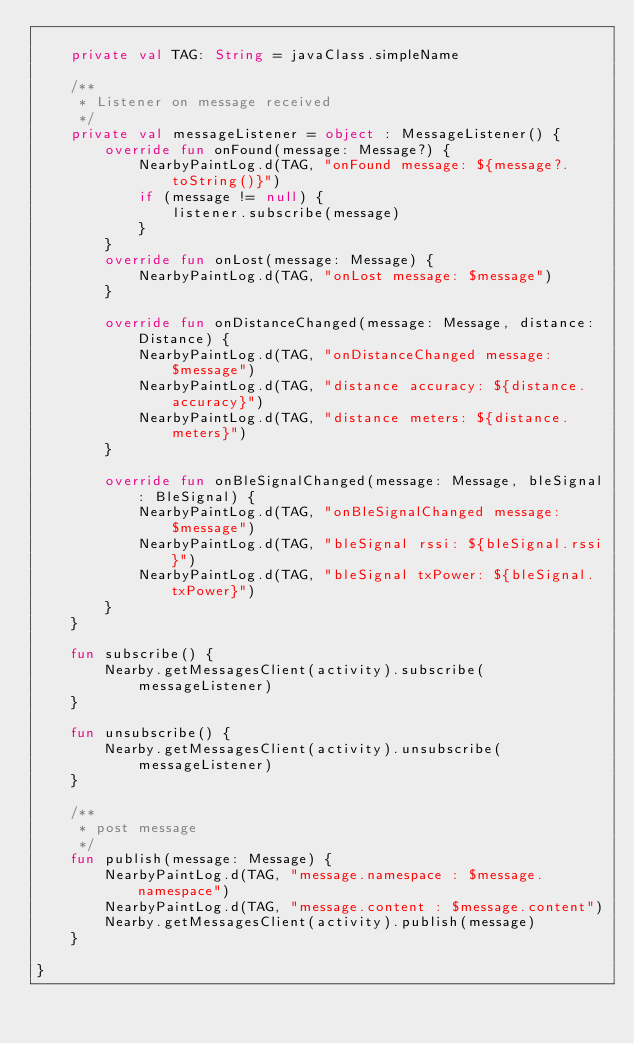Convert code to text. <code><loc_0><loc_0><loc_500><loc_500><_Kotlin_>
    private val TAG: String = javaClass.simpleName

    /**
     * Listener on message received
     */
    private val messageListener = object : MessageListener() {
        override fun onFound(message: Message?) {
            NearbyPaintLog.d(TAG, "onFound message: ${message?.toString()}")
            if (message != null) {
                listener.subscribe(message)
            }
        }
        override fun onLost(message: Message) {
            NearbyPaintLog.d(TAG, "onLost message: $message")
        }

        override fun onDistanceChanged(message: Message, distance: Distance) {
            NearbyPaintLog.d(TAG, "onDistanceChanged message: $message")
            NearbyPaintLog.d(TAG, "distance accuracy: ${distance.accuracy}")
            NearbyPaintLog.d(TAG, "distance meters: ${distance.meters}")
        }

        override fun onBleSignalChanged(message: Message, bleSignal: BleSignal) {
            NearbyPaintLog.d(TAG, "onBleSignalChanged message: $message")
            NearbyPaintLog.d(TAG, "bleSignal rssi: ${bleSignal.rssi}")
            NearbyPaintLog.d(TAG, "bleSignal txPower: ${bleSignal.txPower}")
        }
    }

    fun subscribe() {
        Nearby.getMessagesClient(activity).subscribe(messageListener)
    }

    fun unsubscribe() {
        Nearby.getMessagesClient(activity).unsubscribe(messageListener)
    }

    /**
     * post message
     */
    fun publish(message: Message) {
        NearbyPaintLog.d(TAG, "message.namespace : $message.namespace")
        NearbyPaintLog.d(TAG, "message.content : $message.content")
        Nearby.getMessagesClient(activity).publish(message)
    }

}</code> 